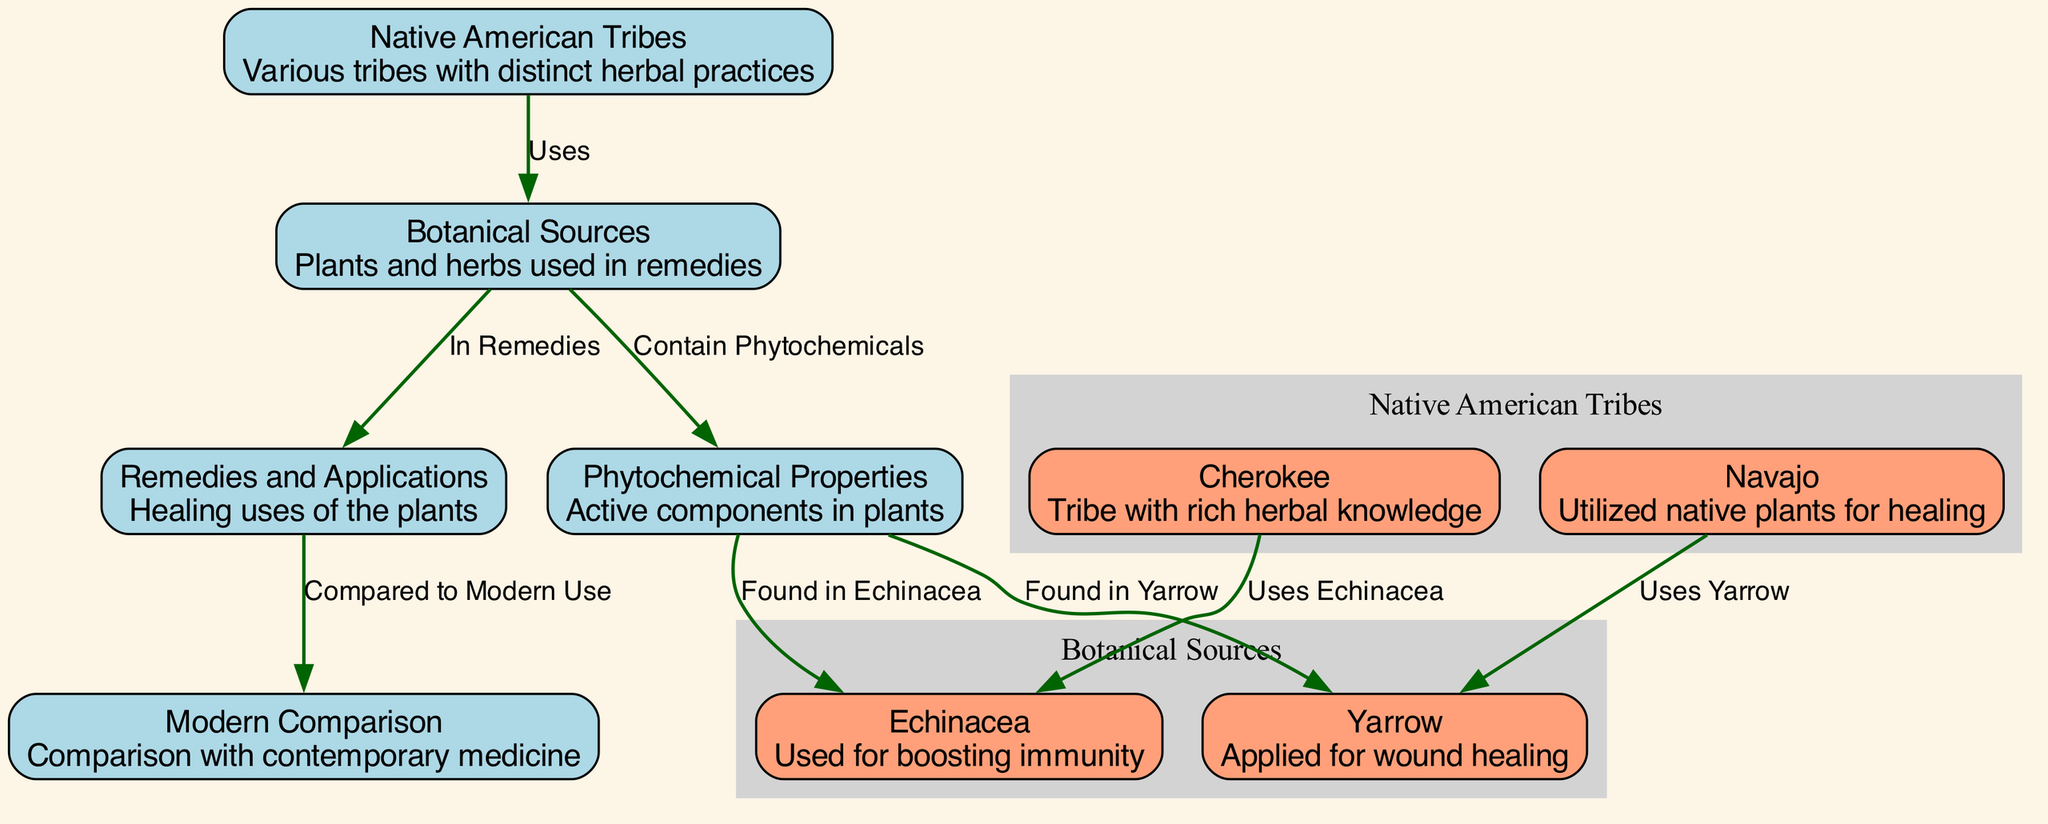What is the primary focus of the diagram? The diagram focuses on the evolution and comparative analysis of Native American herbal remedies, showing the relationships between tribes, plants, their uses, and comparisons with modern medicine.
Answer: Native American herbal remedies How many Native American tribes are represented? There are two Native American tribes represented in the diagram, which are Cherokee and Navajo. Each tribe is linked to specific herbal practices.
Answer: 2 Which plant is used by the Cherokee tribe? The plant used by the Cherokee tribe is Echinacea, which is depicted in the diagram with a direct link showing its connection.
Answer: Echinacea What healing application is associated with Yarrow? Yarrow is applied for wound healing, as indicated in the diagram where there is a direct connection between the Navajo tribe and Yarrow.
Answer: Wound healing How are botanical sources related to remedies? The botanical sources are connected to remedies through a direct link, indicating that these plant sources are used in various healing applications.
Answer: Uses Which components are found in Echinacea? Echinacea contains phytochemical properties, showing the active components found in that specific plant as indicated in the diagram.
Answer: Phytochemicals What is the relationship between remedies and modern comparison? The relationship illustrated is that remedies derived from the plants are compared to modern medicinal practices, highlighting the evolution of their uses.
Answer: Compared to Modern Use What common feature do both Echinacea and Yarrow share according to the diagram? Both Echinacea and Yarrow share the common feature of containing phytochemicals, as shown in the connections that lead from the phytochemical properties node to each of these plants.
Answer: Phytochemicals How many edges are present in the diagram? There are a total of seven edges shown in the diagram indicating the various relationships between the nodes.
Answer: 7 